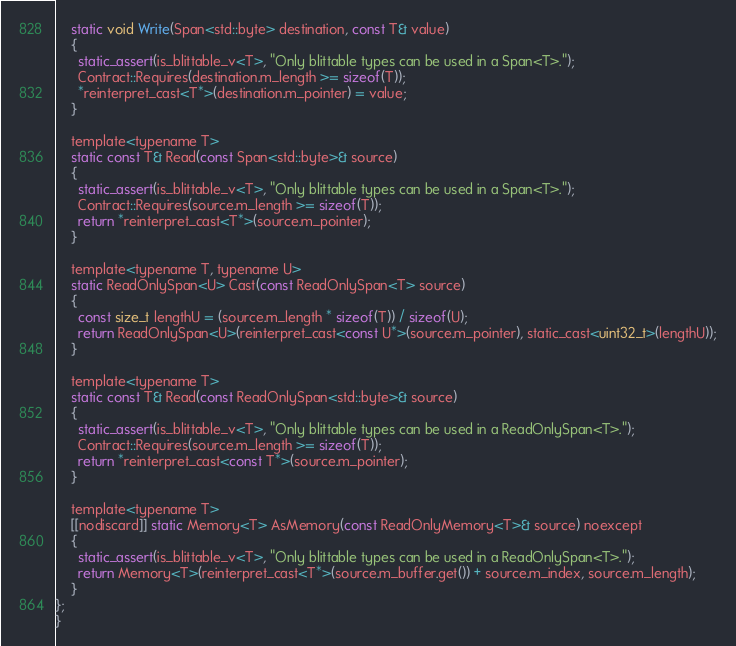<code> <loc_0><loc_0><loc_500><loc_500><_C_>    static void Write(Span<std::byte> destination, const T& value)
    {
      static_assert(is_blittable_v<T>, "Only blittable types can be used in a Span<T>.");
      Contract::Requires(destination.m_length >= sizeof(T));
      *reinterpret_cast<T*>(destination.m_pointer) = value;
    }

    template<typename T>
    static const T& Read(const Span<std::byte>& source)
    {
      static_assert(is_blittable_v<T>, "Only blittable types can be used in a Span<T>.");
      Contract::Requires(source.m_length >= sizeof(T));
      return *reinterpret_cast<T*>(source.m_pointer);
    }

    template<typename T, typename U>
    static ReadOnlySpan<U> Cast(const ReadOnlySpan<T> source)
    {
      const size_t lengthU = (source.m_length * sizeof(T)) / sizeof(U);
      return ReadOnlySpan<U>(reinterpret_cast<const U*>(source.m_pointer), static_cast<uint32_t>(lengthU));
    }

    template<typename T>
    static const T& Read(const ReadOnlySpan<std::byte>& source)
    {
      static_assert(is_blittable_v<T>, "Only blittable types can be used in a ReadOnlySpan<T>.");
      Contract::Requires(source.m_length >= sizeof(T));
      return *reinterpret_cast<const T*>(source.m_pointer);
    }

    template<typename T>
    [[nodiscard]] static Memory<T> AsMemory(const ReadOnlyMemory<T>& source) noexcept
    {
      static_assert(is_blittable_v<T>, "Only blittable types can be used in a ReadOnlySpan<T>.");
      return Memory<T>(reinterpret_cast<T*>(source.m_buffer.get()) + source.m_index, source.m_length);
    }
};
}
</code> 